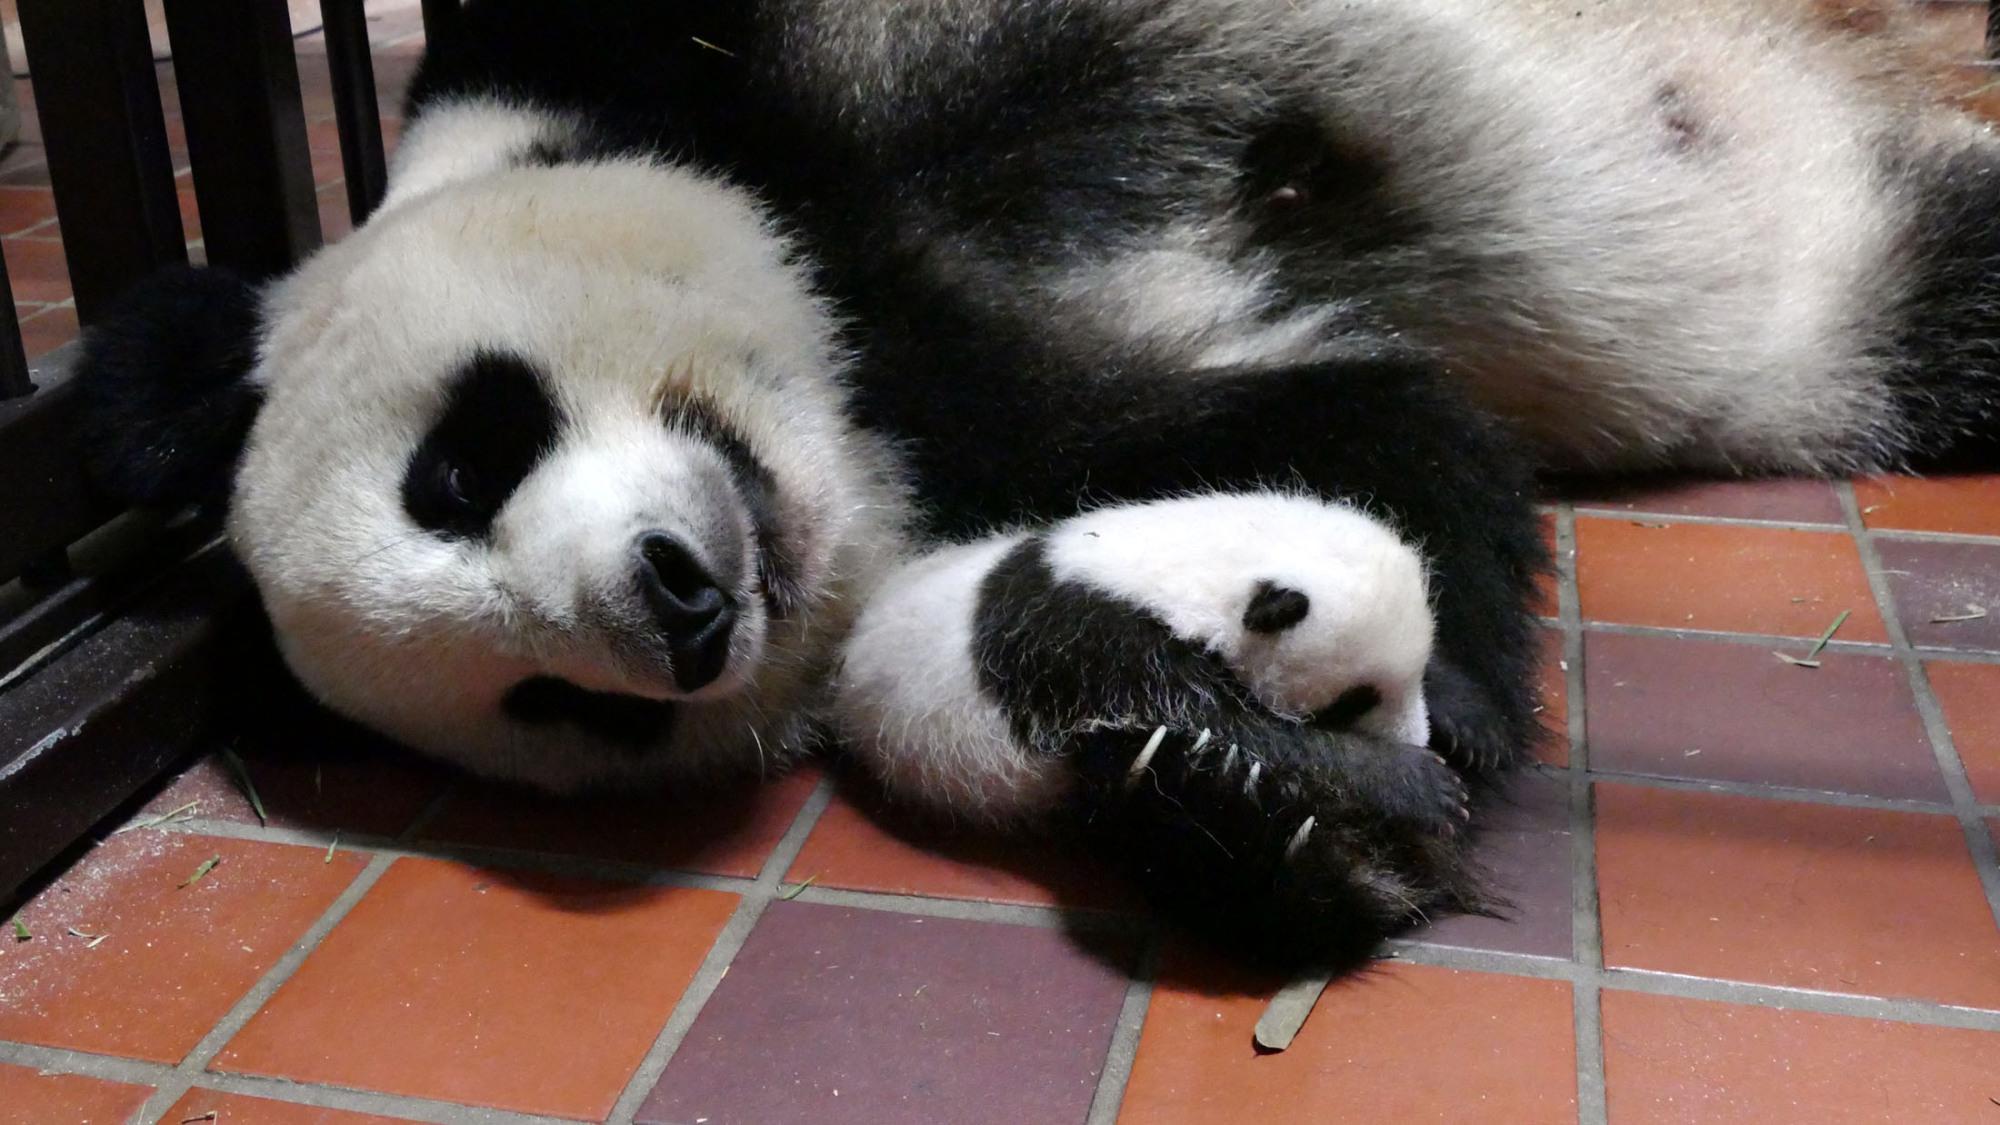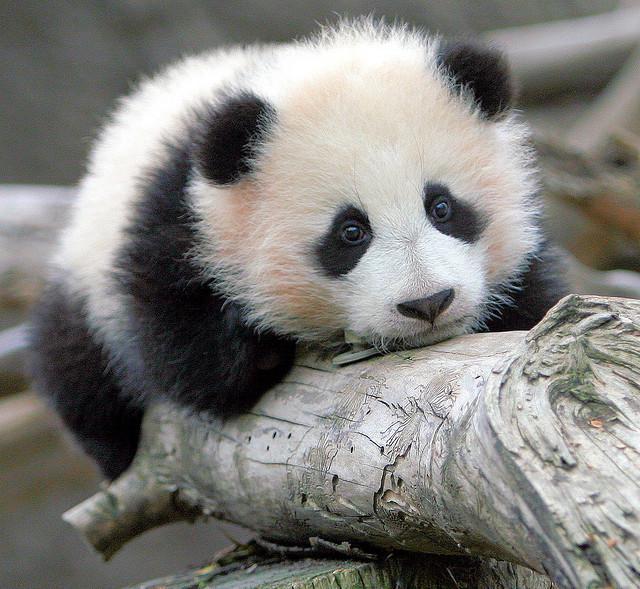The first image is the image on the left, the second image is the image on the right. Assess this claim about the two images: "There is at least one human face behind a panda bear.". Correct or not? Answer yes or no. No. 